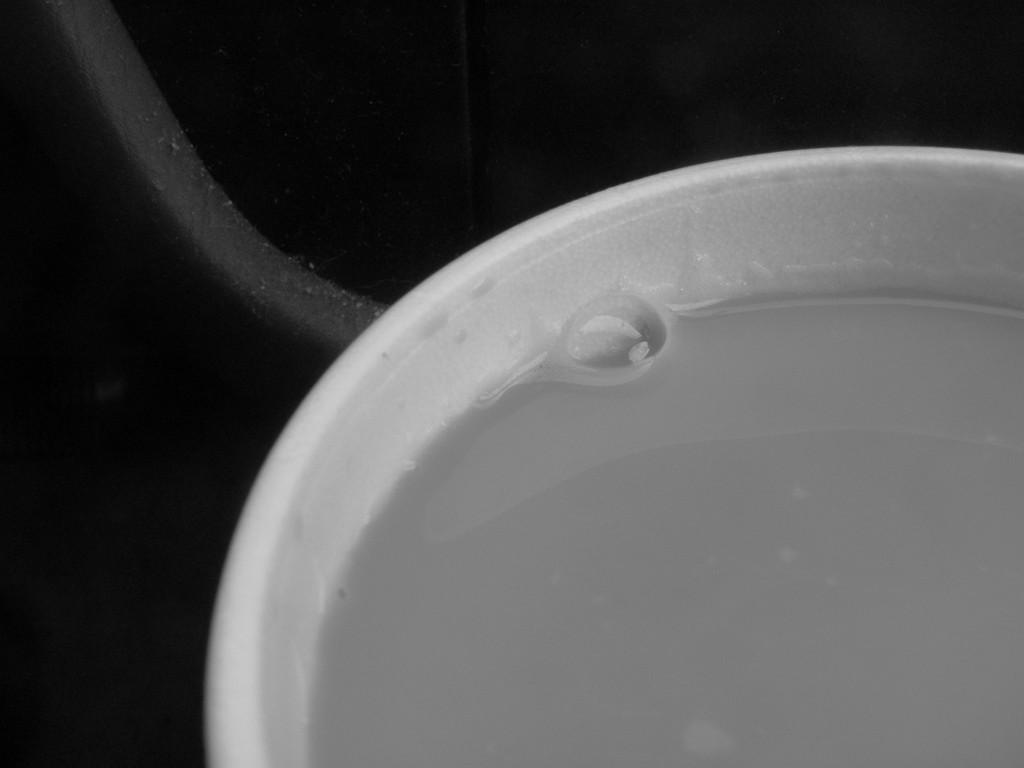What is the color scheme of the image? The image is black and white. What can be seen on the right side of the image? There is an object with liquid and a bubble on the right side of the image. What is located behind the object with liquid and a bubble? There is an object that looks like a rod behind the object with liquid and a bubble. How many brothers are depicted in the image? There are no people, let alone brothers, depicted in the image. 